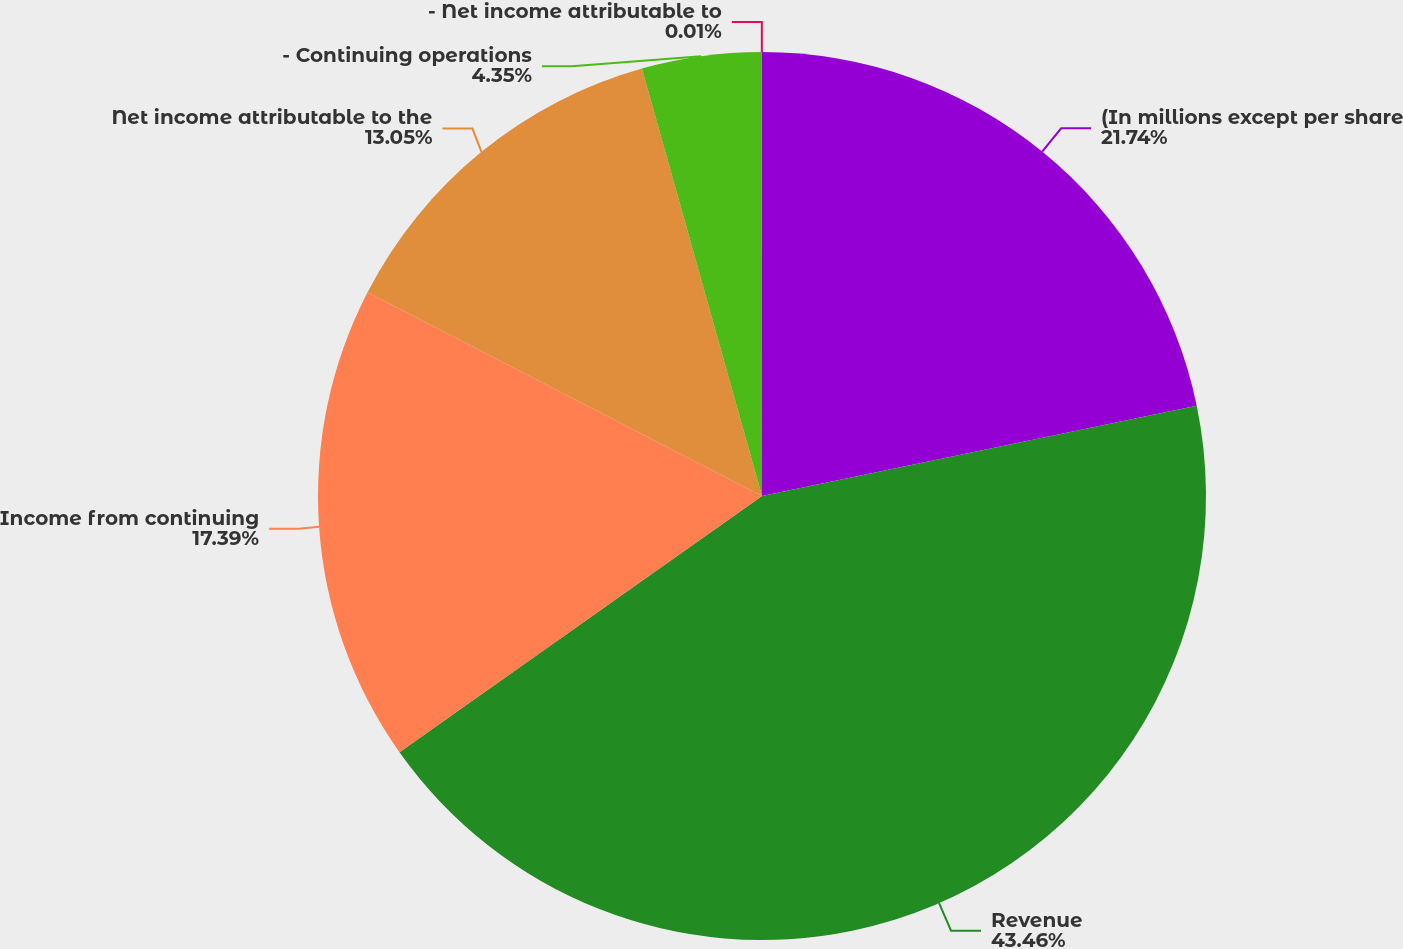<chart> <loc_0><loc_0><loc_500><loc_500><pie_chart><fcel>(In millions except per share<fcel>Revenue<fcel>Income from continuing<fcel>Net income attributable to the<fcel>- Continuing operations<fcel>- Net income attributable to<nl><fcel>21.74%<fcel>43.47%<fcel>17.39%<fcel>13.05%<fcel>4.35%<fcel>0.01%<nl></chart> 